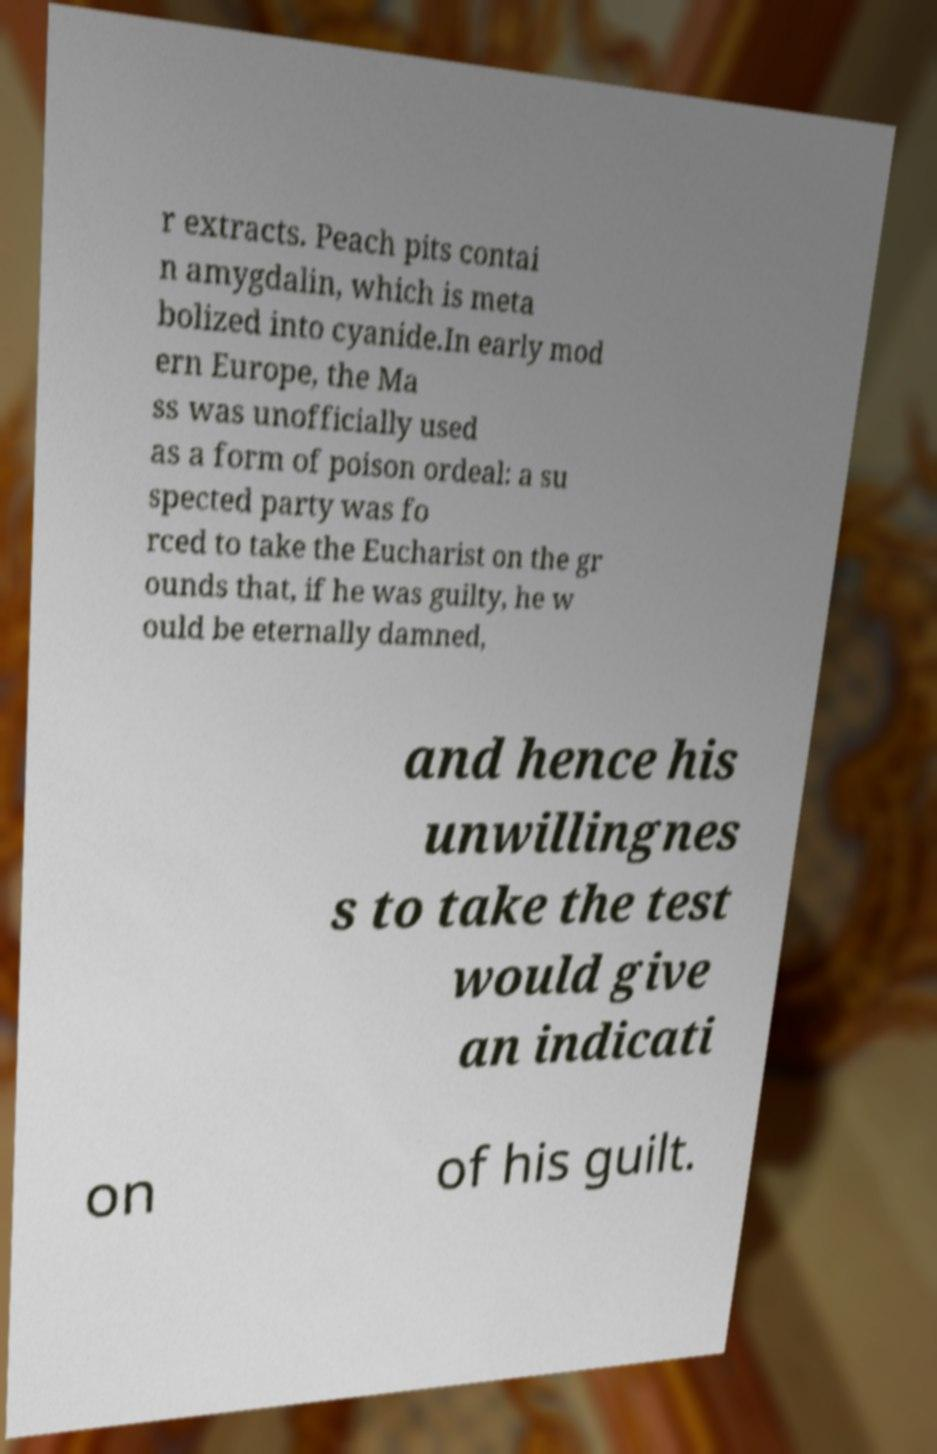Please identify and transcribe the text found in this image. r extracts. Peach pits contai n amygdalin, which is meta bolized into cyanide.In early mod ern Europe, the Ma ss was unofficially used as a form of poison ordeal: a su spected party was fo rced to take the Eucharist on the gr ounds that, if he was guilty, he w ould be eternally damned, and hence his unwillingnes s to take the test would give an indicati on of his guilt. 